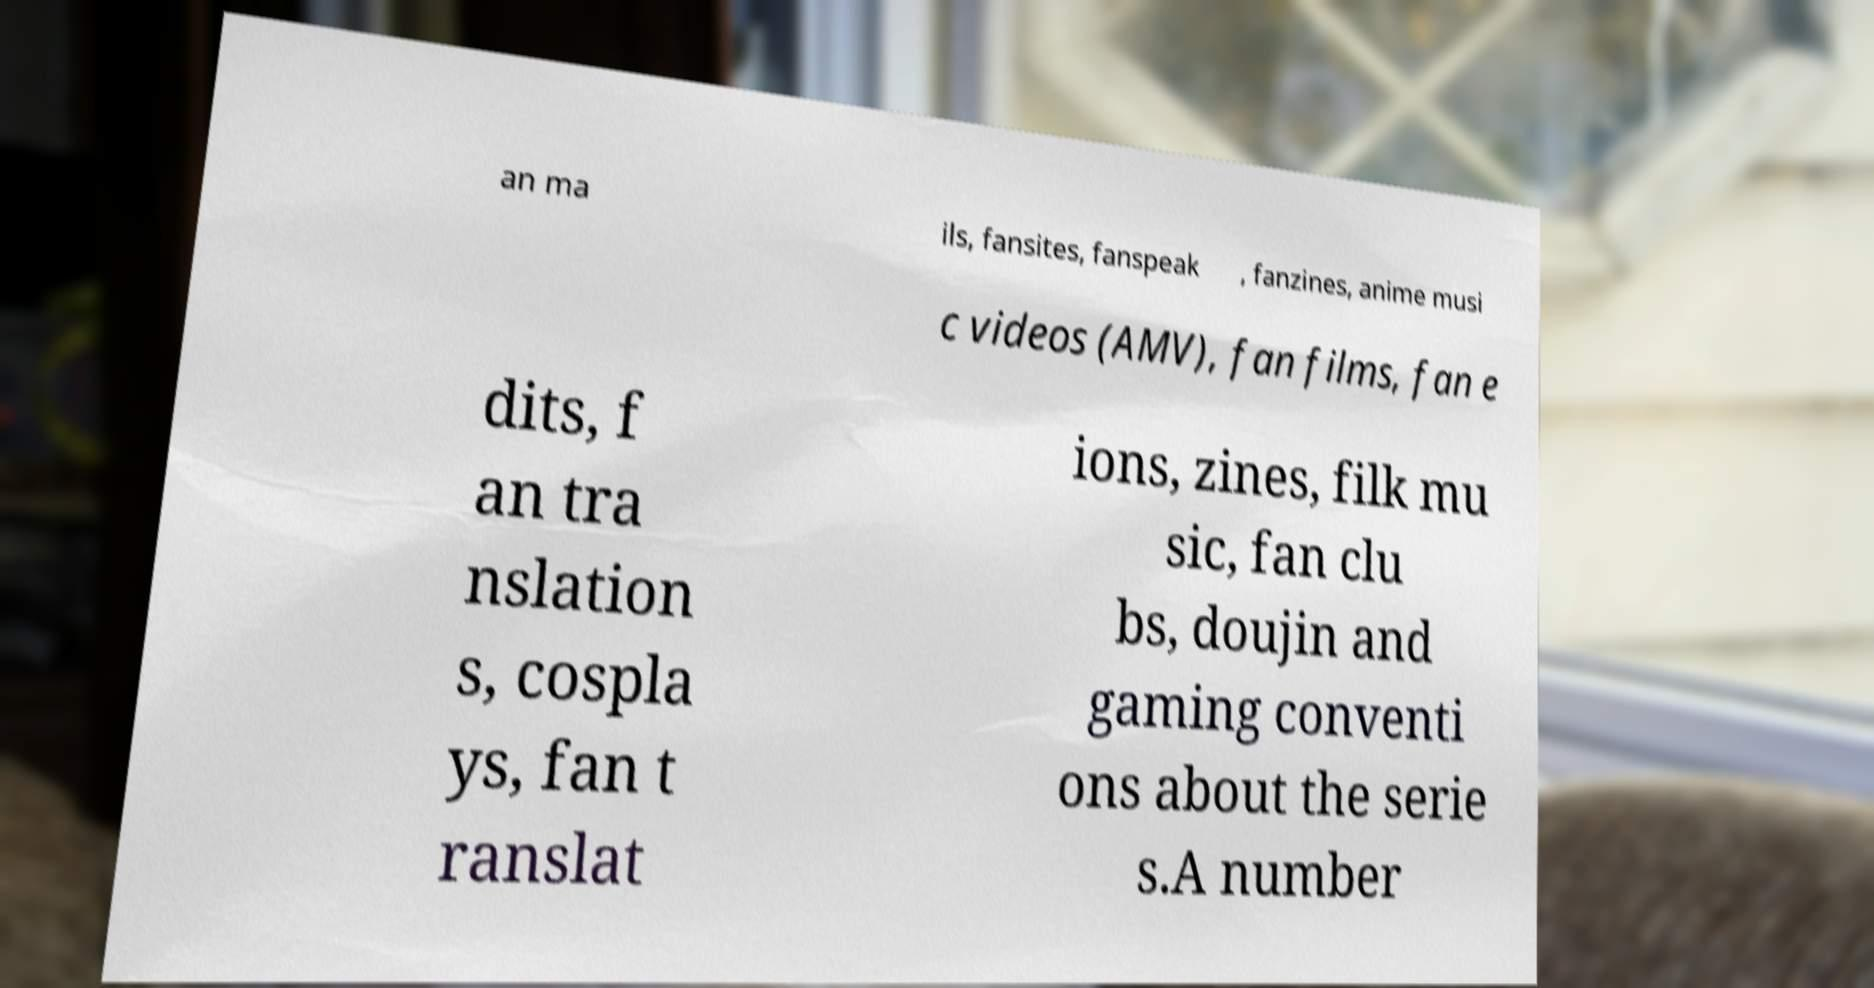What messages or text are displayed in this image? I need them in a readable, typed format. an ma ils, fansites, fanspeak , fanzines, anime musi c videos (AMV), fan films, fan e dits, f an tra nslation s, cospla ys, fan t ranslat ions, zines, filk mu sic, fan clu bs, doujin and gaming conventi ons about the serie s.A number 